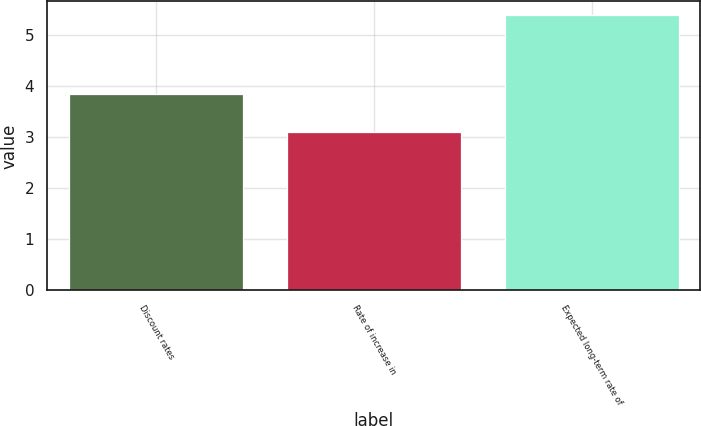Convert chart. <chart><loc_0><loc_0><loc_500><loc_500><bar_chart><fcel>Discount rates<fcel>Rate of increase in<fcel>Expected long-term rate of<nl><fcel>3.85<fcel>3.11<fcel>5.39<nl></chart> 